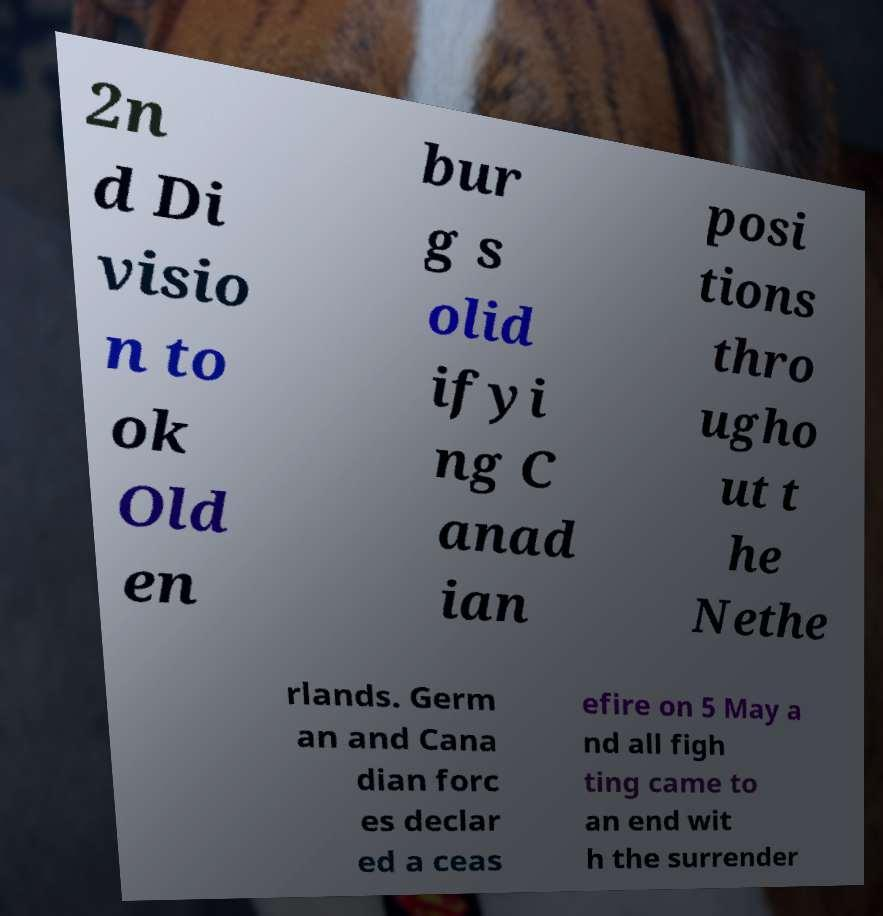Can you read and provide the text displayed in the image?This photo seems to have some interesting text. Can you extract and type it out for me? 2n d Di visio n to ok Old en bur g s olid ifyi ng C anad ian posi tions thro ugho ut t he Nethe rlands. Germ an and Cana dian forc es declar ed a ceas efire on 5 May a nd all figh ting came to an end wit h the surrender 